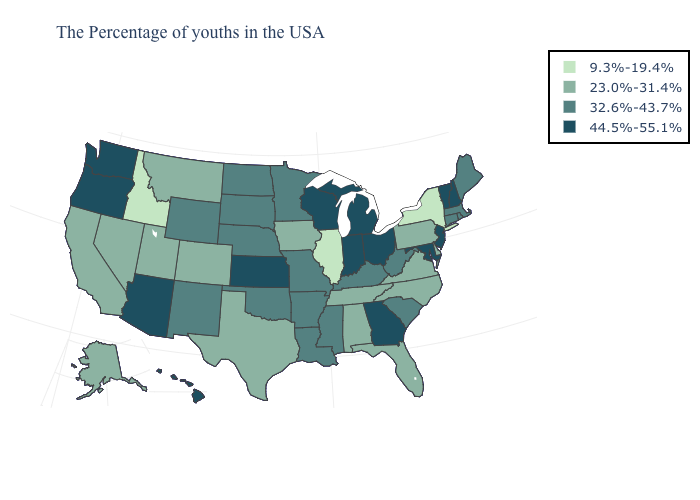Which states have the lowest value in the Northeast?
Quick response, please. New York. What is the value of New York?
Concise answer only. 9.3%-19.4%. Does the first symbol in the legend represent the smallest category?
Be succinct. Yes. What is the value of Wisconsin?
Short answer required. 44.5%-55.1%. How many symbols are there in the legend?
Write a very short answer. 4. Name the states that have a value in the range 32.6%-43.7%?
Keep it brief. Maine, Massachusetts, Rhode Island, Connecticut, South Carolina, West Virginia, Kentucky, Mississippi, Louisiana, Missouri, Arkansas, Minnesota, Nebraska, Oklahoma, South Dakota, North Dakota, Wyoming, New Mexico. Name the states that have a value in the range 9.3%-19.4%?
Quick response, please. New York, Illinois, Idaho. Which states have the lowest value in the MidWest?
Give a very brief answer. Illinois. What is the value of Florida?
Answer briefly. 23.0%-31.4%. Does New Jersey have the lowest value in the USA?
Be succinct. No. Does North Carolina have the highest value in the USA?
Keep it brief. No. Name the states that have a value in the range 23.0%-31.4%?
Keep it brief. Delaware, Pennsylvania, Virginia, North Carolina, Florida, Alabama, Tennessee, Iowa, Texas, Colorado, Utah, Montana, Nevada, California, Alaska. Does the first symbol in the legend represent the smallest category?
Write a very short answer. Yes. Does the first symbol in the legend represent the smallest category?
Give a very brief answer. Yes. Name the states that have a value in the range 44.5%-55.1%?
Concise answer only. New Hampshire, Vermont, New Jersey, Maryland, Ohio, Georgia, Michigan, Indiana, Wisconsin, Kansas, Arizona, Washington, Oregon, Hawaii. 